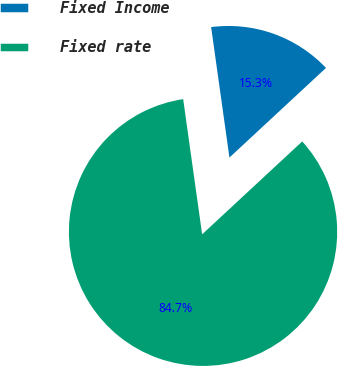Convert chart. <chart><loc_0><loc_0><loc_500><loc_500><pie_chart><fcel>Fixed Income<fcel>Fixed rate<nl><fcel>15.31%<fcel>84.69%<nl></chart> 